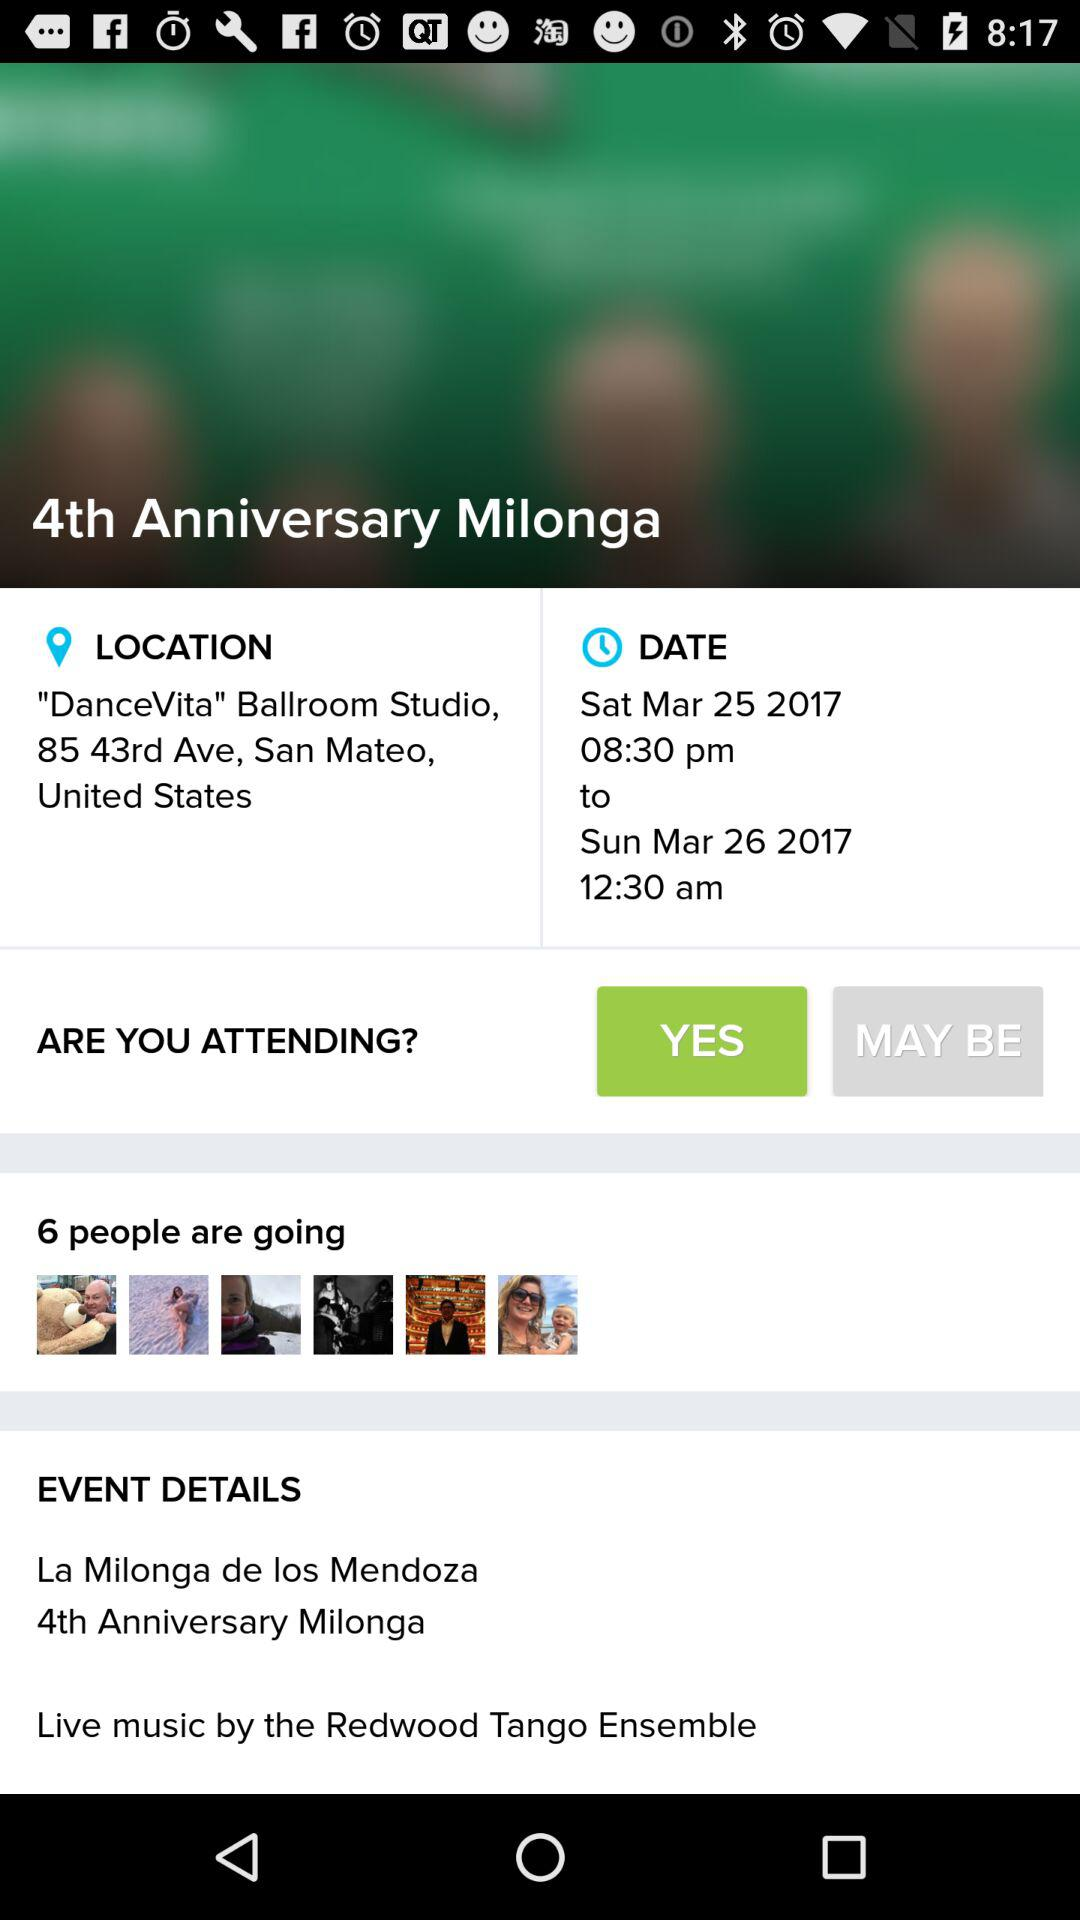How many artists and artisans are coming? There are over 75 quality local and Bay Area artists and artisans coming. 